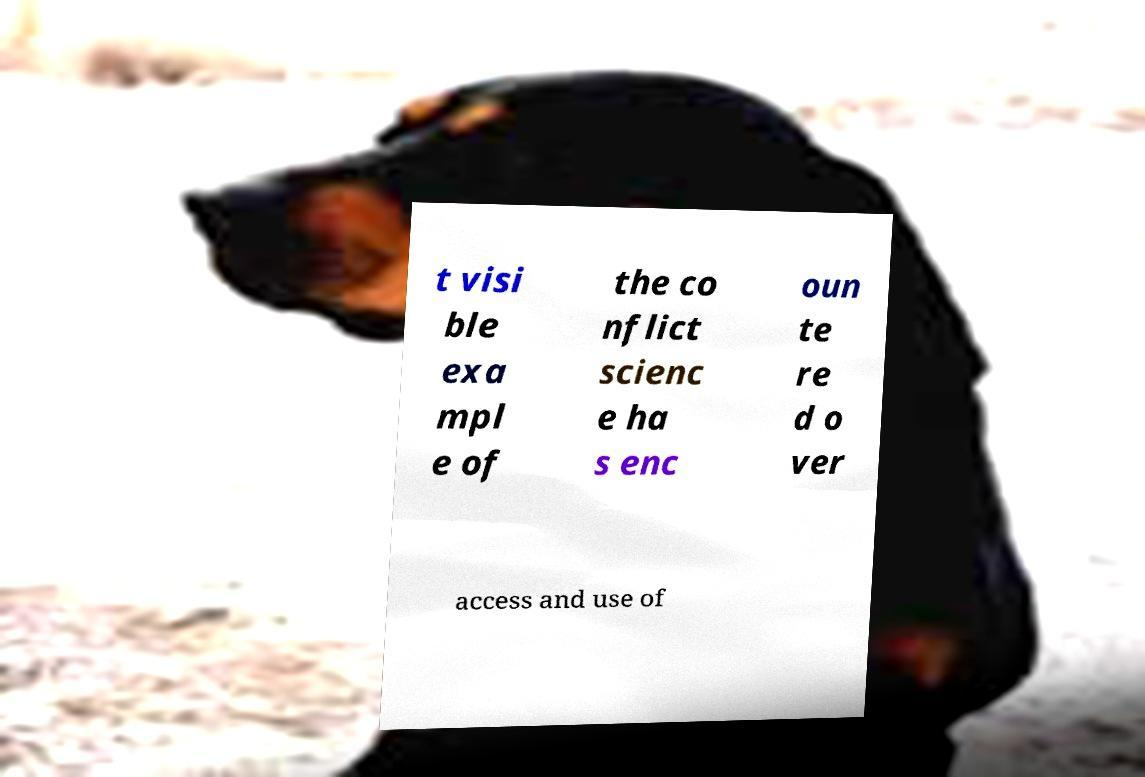Please identify and transcribe the text found in this image. t visi ble exa mpl e of the co nflict scienc e ha s enc oun te re d o ver access and use of 